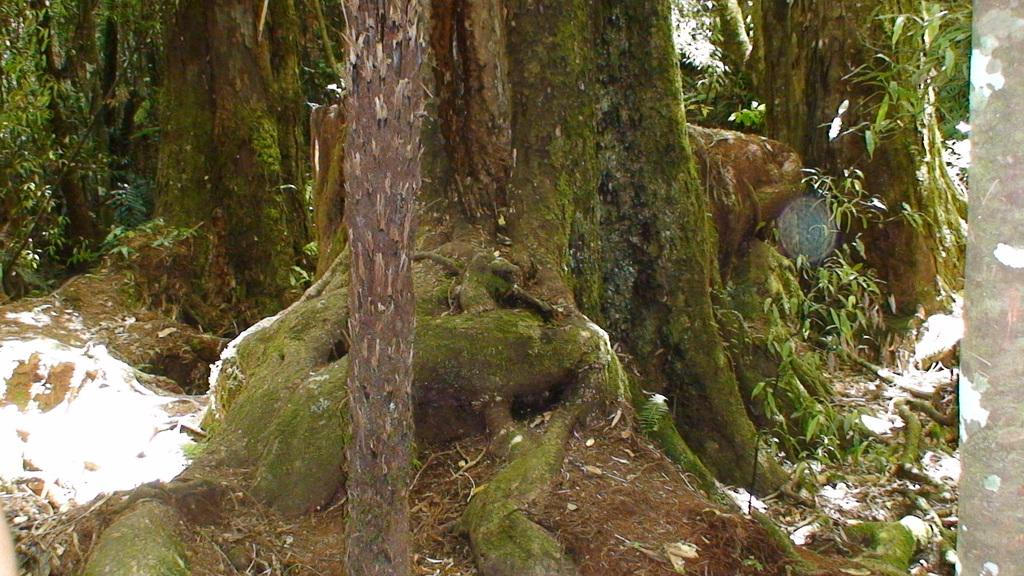What type of plant structures can be seen in the image? There are tree trunks and leaves in the image. Can you describe the tree trunks in the image? The tree trunks are the main stems of the trees, providing support and transporting nutrients. What can be inferred about the trees based on the presence of leaves? The presence of leaves suggests that the trees are alive and capable of photosynthesis. What type of whistle can be heard coming from the tree trunks in the image? There is no whistle present in the image, as it only features tree trunks and leaves. 